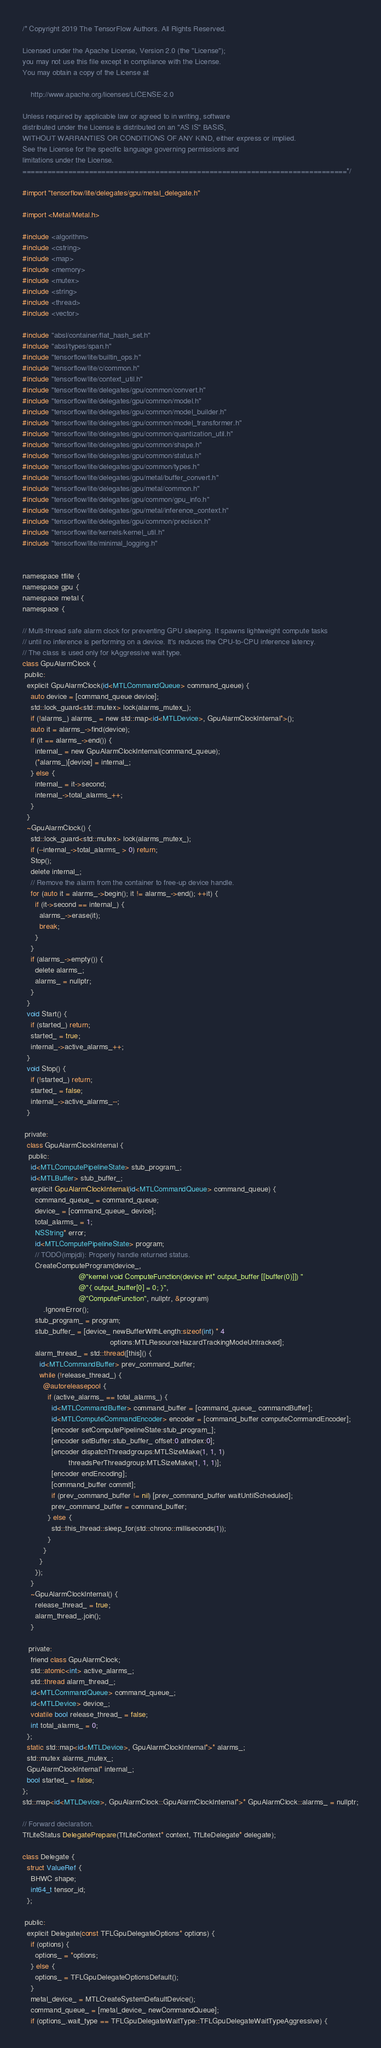Convert code to text. <code><loc_0><loc_0><loc_500><loc_500><_ObjectiveC_>/* Copyright 2019 The TensorFlow Authors. All Rights Reserved.

Licensed under the Apache License, Version 2.0 (the "License");
you may not use this file except in compliance with the License.
You may obtain a copy of the License at

    http://www.apache.org/licenses/LICENSE-2.0

Unless required by applicable law or agreed to in writing, software
distributed under the License is distributed on an "AS IS" BASIS,
WITHOUT WARRANTIES OR CONDITIONS OF ANY KIND, either express or implied.
See the License for the specific language governing permissions and
limitations under the License.
==============================================================================*/

#import "tensorflow/lite/delegates/gpu/metal_delegate.h"

#import <Metal/Metal.h>

#include <algorithm>
#include <cstring>
#include <map>
#include <memory>
#include <mutex>
#include <string>
#include <thread>
#include <vector>

#include "absl/container/flat_hash_set.h"
#include "absl/types/span.h"
#include "tensorflow/lite/builtin_ops.h"
#include "tensorflow/lite/c/common.h"
#include "tensorflow/lite/context_util.h"
#include "tensorflow/lite/delegates/gpu/common/convert.h"
#include "tensorflow/lite/delegates/gpu/common/model.h"
#include "tensorflow/lite/delegates/gpu/common/model_builder.h"
#include "tensorflow/lite/delegates/gpu/common/model_transformer.h"
#include "tensorflow/lite/delegates/gpu/common/quantization_util.h"
#include "tensorflow/lite/delegates/gpu/common/shape.h"
#include "tensorflow/lite/delegates/gpu/common/status.h"
#include "tensorflow/lite/delegates/gpu/common/types.h"
#include "tensorflow/lite/delegates/gpu/metal/buffer_convert.h"
#include "tensorflow/lite/delegates/gpu/metal/common.h"
#include "tensorflow/lite/delegates/gpu/common/gpu_info.h"
#include "tensorflow/lite/delegates/gpu/metal/inference_context.h"
#include "tensorflow/lite/delegates/gpu/common/precision.h"
#include "tensorflow/lite/kernels/kernel_util.h"
#include "tensorflow/lite/minimal_logging.h"


namespace tflite {
namespace gpu {
namespace metal {
namespace {

// Multi-thread safe alarm clock for preventing GPU sleeping. It spawns lightweight compute tasks
// until no inference is performing on a device. It's reduces the CPU-to-CPU inference latency.
// The class is used only for kAggressive wait type.
class GpuAlarmClock {
 public:
  explicit GpuAlarmClock(id<MTLCommandQueue> command_queue) {
    auto device = [command_queue device];
    std::lock_guard<std::mutex> lock(alarms_mutex_);
    if (!alarms_) alarms_ = new std::map<id<MTLDevice>, GpuAlarmClockInternal*>();
    auto it = alarms_->find(device);
    if (it == alarms_->end()) {
      internal_ = new GpuAlarmClockInternal(command_queue);
      (*alarms_)[device] = internal_;
    } else {
      internal_ = it->second;
      internal_->total_alarms_++;
    }
  }
  ~GpuAlarmClock() {
    std::lock_guard<std::mutex> lock(alarms_mutex_);
    if (--internal_->total_alarms_ > 0) return;
    Stop();
    delete internal_;
    // Remove the alarm from the container to free-up device handle.
    for (auto it = alarms_->begin(); it != alarms_->end(); ++it) {
      if (it->second == internal_) {
        alarms_->erase(it);
        break;
      }
    }
    if (alarms_->empty()) {
      delete alarms_;
      alarms_ = nullptr;
    }
  }
  void Start() {
    if (started_) return;
    started_ = true;
    internal_->active_alarms_++;
  }
  void Stop() {
    if (!started_) return;
    started_ = false;
    internal_->active_alarms_--;
  }

 private:
  class GpuAlarmClockInternal {
   public:
    id<MTLComputePipelineState> stub_program_;
    id<MTLBuffer> stub_buffer_;
    explicit GpuAlarmClockInternal(id<MTLCommandQueue> command_queue) {
      command_queue_ = command_queue;
      device_ = [command_queue_ device];
      total_alarms_ = 1;
      NSString* error;
      id<MTLComputePipelineState> program;
      // TODO(impjdi): Properly handle returned status.
      CreateComputeProgram(device_,
                           @"kernel void ComputeFunction(device int* output_buffer [[buffer(0)]]) "
                           @"{ output_buffer[0] = 0; }",
                           @"ComputeFunction", nullptr, &program)
          .IgnoreError();
      stub_program_ = program;
      stub_buffer_ = [device_ newBufferWithLength:sizeof(int) * 4
                                          options:MTLResourceHazardTrackingModeUntracked];
      alarm_thread_ = std::thread([this]() {
        id<MTLCommandBuffer> prev_command_buffer;
        while (!release_thread_) {
          @autoreleasepool {
            if (active_alarms_ == total_alarms_) {
              id<MTLCommandBuffer> command_buffer = [command_queue_ commandBuffer];
              id<MTLComputeCommandEncoder> encoder = [command_buffer computeCommandEncoder];
              [encoder setComputePipelineState:stub_program_];
              [encoder setBuffer:stub_buffer_ offset:0 atIndex:0];
              [encoder dispatchThreadgroups:MTLSizeMake(1, 1, 1)
                      threadsPerThreadgroup:MTLSizeMake(1, 1, 1)];
              [encoder endEncoding];
              [command_buffer commit];
              if (prev_command_buffer != nil) [prev_command_buffer waitUntilScheduled];
              prev_command_buffer = command_buffer;
            } else {
              std::this_thread::sleep_for(std::chrono::milliseconds(1));
            }
          }
        }
      });
    }
    ~GpuAlarmClockInternal() {
      release_thread_ = true;
      alarm_thread_.join();
    }

   private:
    friend class GpuAlarmClock;
    std::atomic<int> active_alarms_;
    std::thread alarm_thread_;
    id<MTLCommandQueue> command_queue_;
    id<MTLDevice> device_;
    volatile bool release_thread_ = false;
    int total_alarms_ = 0;
  };
  static std::map<id<MTLDevice>, GpuAlarmClockInternal*>* alarms_;
  std::mutex alarms_mutex_;
  GpuAlarmClockInternal* internal_;
  bool started_ = false;
};
std::map<id<MTLDevice>, GpuAlarmClock::GpuAlarmClockInternal*>* GpuAlarmClock::alarms_ = nullptr;

// Forward declaration.
TfLiteStatus DelegatePrepare(TfLiteContext* context, TfLiteDelegate* delegate);

class Delegate {
  struct ValueRef {
    BHWC shape;
    int64_t tensor_id;
  };

 public:
  explicit Delegate(const TFLGpuDelegateOptions* options) {
    if (options) {
      options_ = *options;
    } else {
      options_ = TFLGpuDelegateOptionsDefault();
    }
    metal_device_ = MTLCreateSystemDefaultDevice();
    command_queue_ = [metal_device_ newCommandQueue];
    if (options_.wait_type == TFLGpuDelegateWaitType::TFLGpuDelegateWaitTypeAggressive) {</code> 